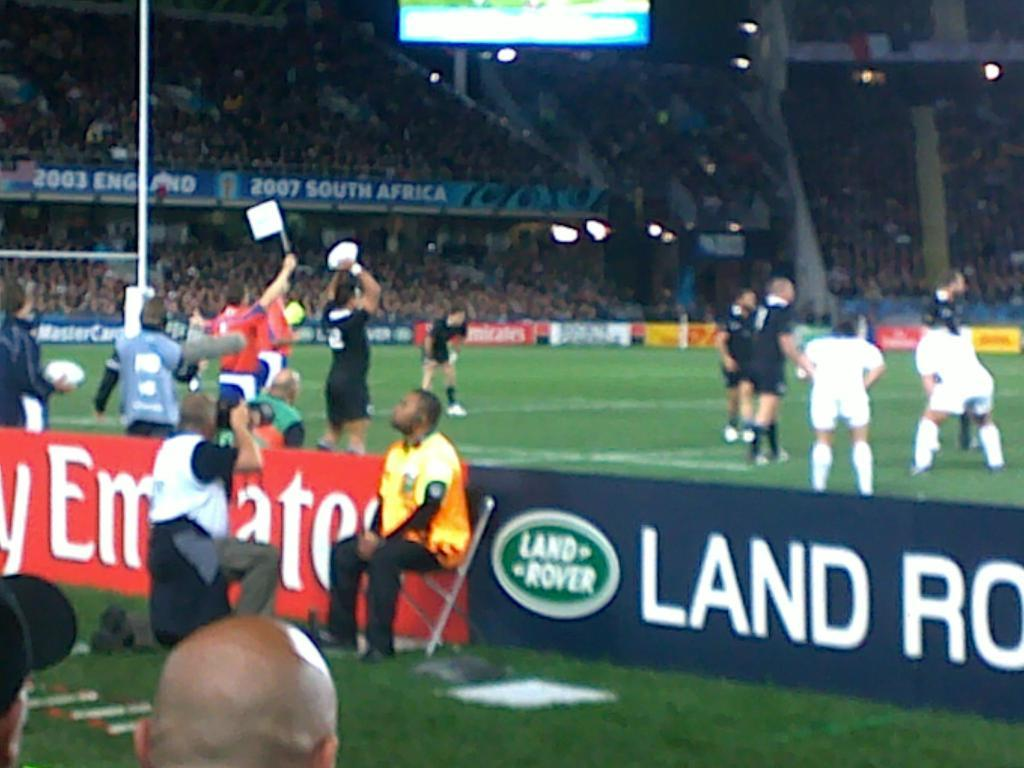Provide a one-sentence caption for the provided image. The soccer players are on the field behind the sign for Land Rover. 